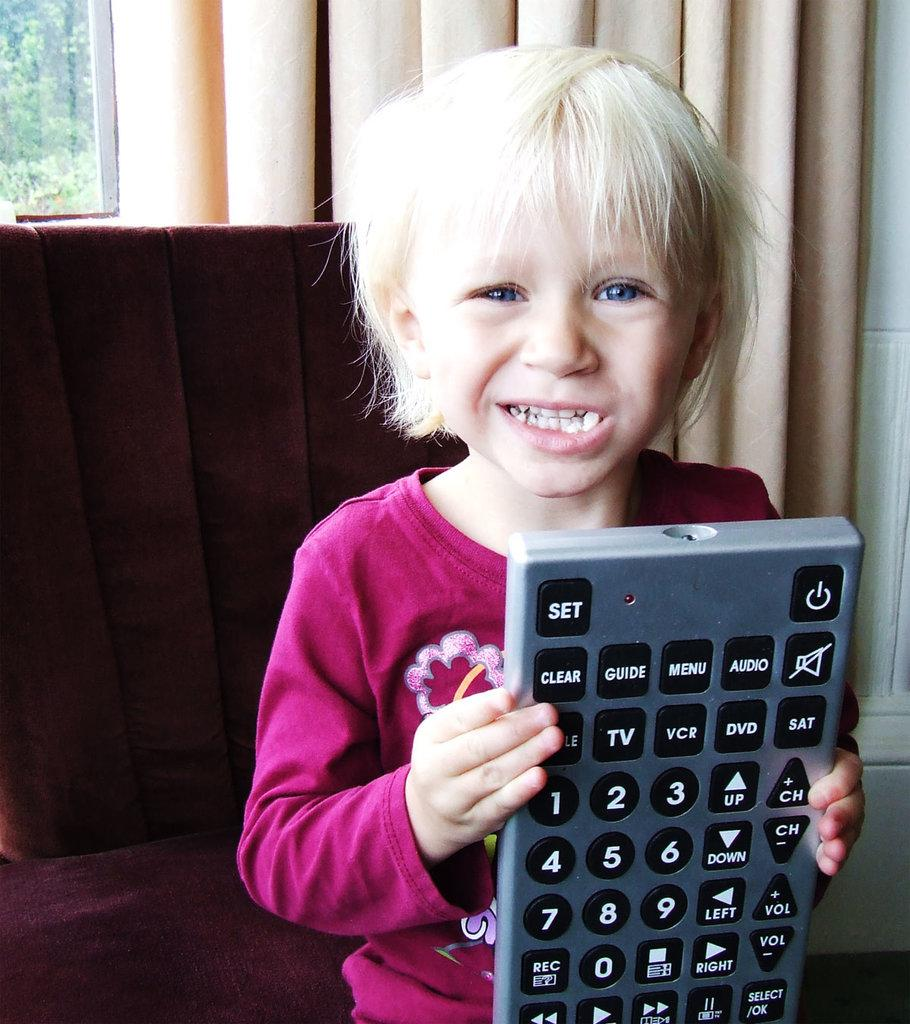<image>
Relay a brief, clear account of the picture shown. The childs finger is close to press the + CH button which would change the channel. 